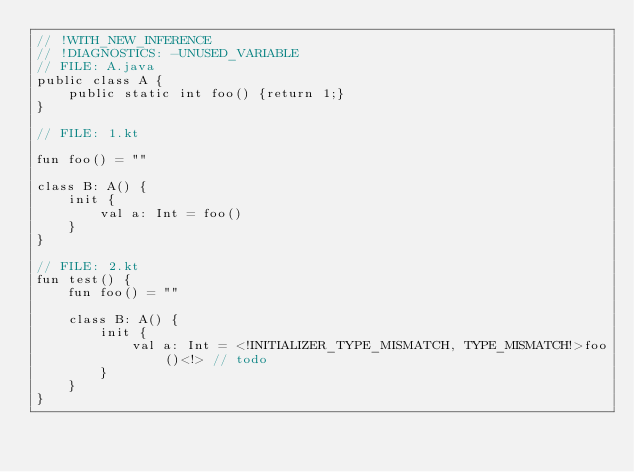Convert code to text. <code><loc_0><loc_0><loc_500><loc_500><_Kotlin_>// !WITH_NEW_INFERENCE
// !DIAGNOSTICS: -UNUSED_VARIABLE
// FILE: A.java
public class A {
    public static int foo() {return 1;}
}

// FILE: 1.kt

fun foo() = ""

class B: A() {
    init {
        val a: Int = foo()
    }
}

// FILE: 2.kt
fun test() {
    fun foo() = ""

    class B: A() {
        init {
            val a: Int = <!INITIALIZER_TYPE_MISMATCH, TYPE_MISMATCH!>foo()<!> // todo
        }
    }
}
</code> 